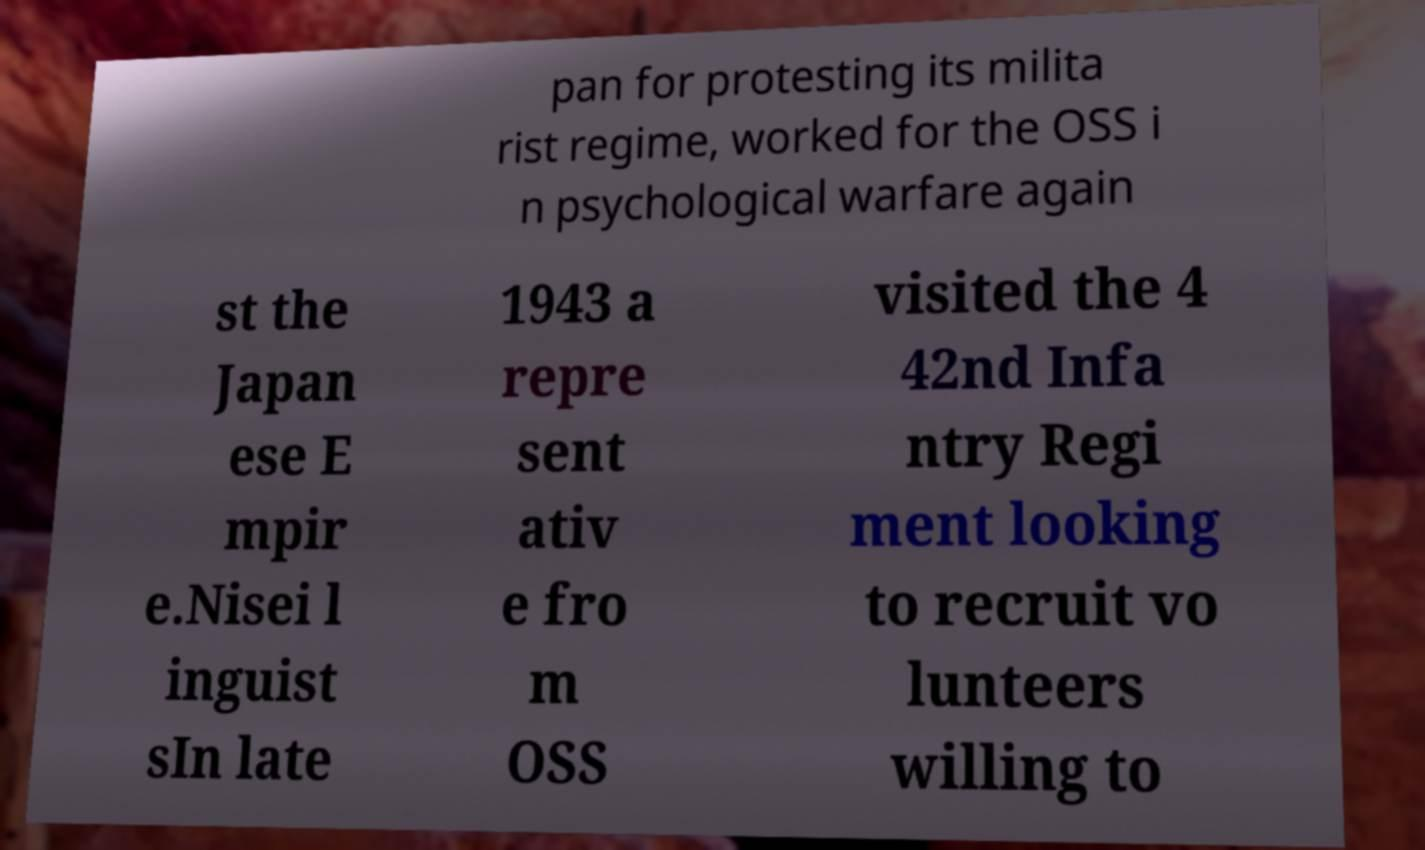For documentation purposes, I need the text within this image transcribed. Could you provide that? pan for protesting its milita rist regime, worked for the OSS i n psychological warfare again st the Japan ese E mpir e.Nisei l inguist sIn late 1943 a repre sent ativ e fro m OSS visited the 4 42nd Infa ntry Regi ment looking to recruit vo lunteers willing to 